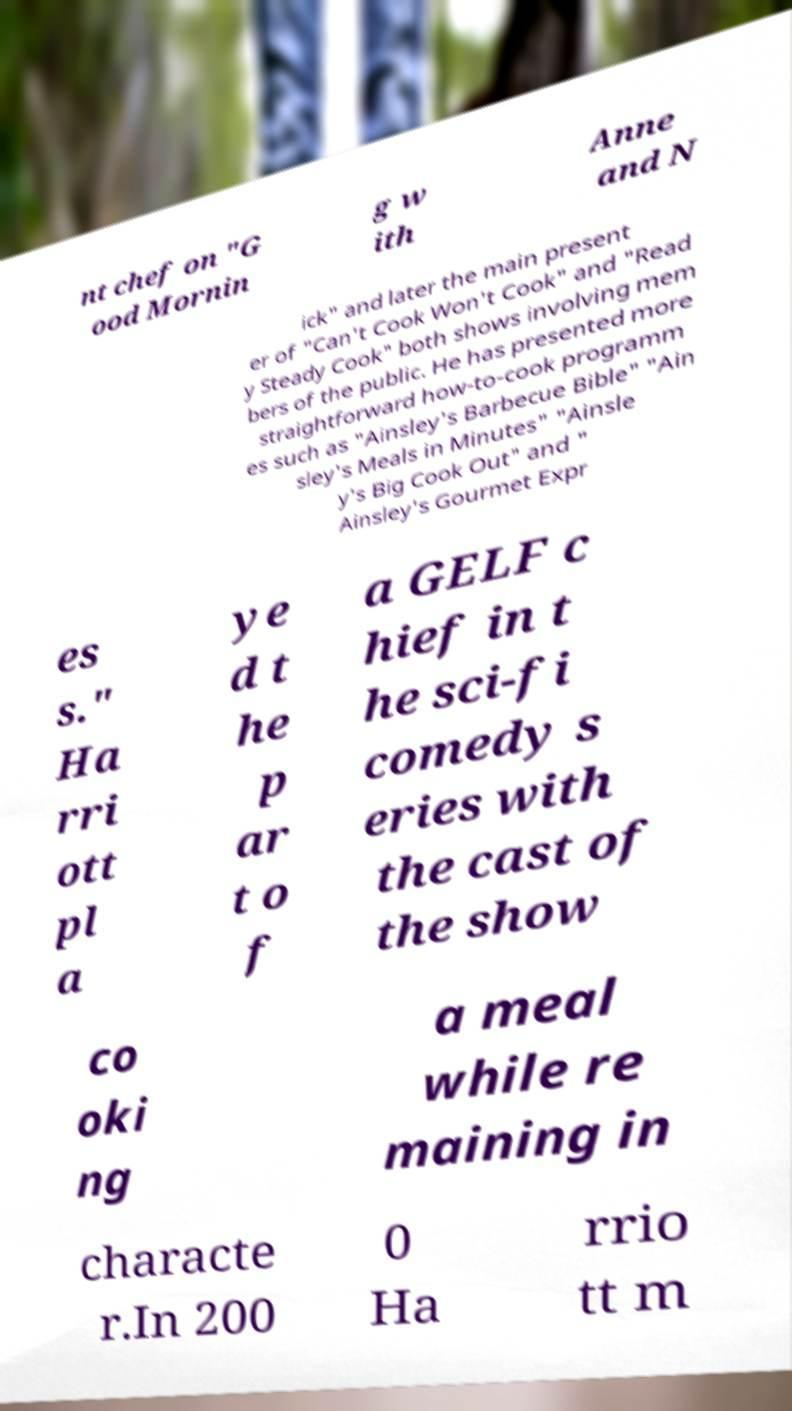Could you extract and type out the text from this image? nt chef on "G ood Mornin g w ith Anne and N ick" and later the main present er of "Can't Cook Won't Cook" and "Read y Steady Cook" both shows involving mem bers of the public. He has presented more straightforward how-to-cook programm es such as "Ainsley's Barbecue Bible" "Ain sley's Meals in Minutes" "Ainsle y's Big Cook Out" and " Ainsley's Gourmet Expr es s." Ha rri ott pl a ye d t he p ar t o f a GELF c hief in t he sci-fi comedy s eries with the cast of the show co oki ng a meal while re maining in characte r.In 200 0 Ha rrio tt m 